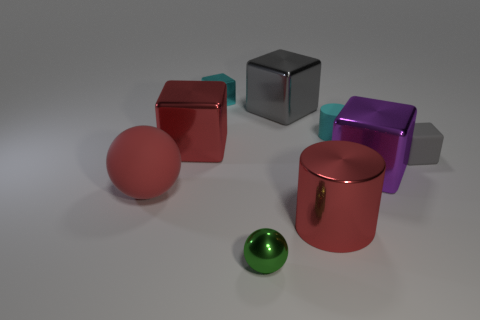Subtract all gray cubes. How many were subtracted if there are1gray cubes left? 1 Subtract all red blocks. How many blocks are left? 4 Subtract all small gray blocks. How many blocks are left? 4 Subtract all blue blocks. Subtract all red cylinders. How many blocks are left? 5 Subtract all spheres. How many objects are left? 7 Add 4 small green balls. How many small green balls are left? 5 Add 4 big metal things. How many big metal things exist? 8 Subtract 0 purple spheres. How many objects are left? 9 Subtract all tiny brown matte cylinders. Subtract all gray things. How many objects are left? 7 